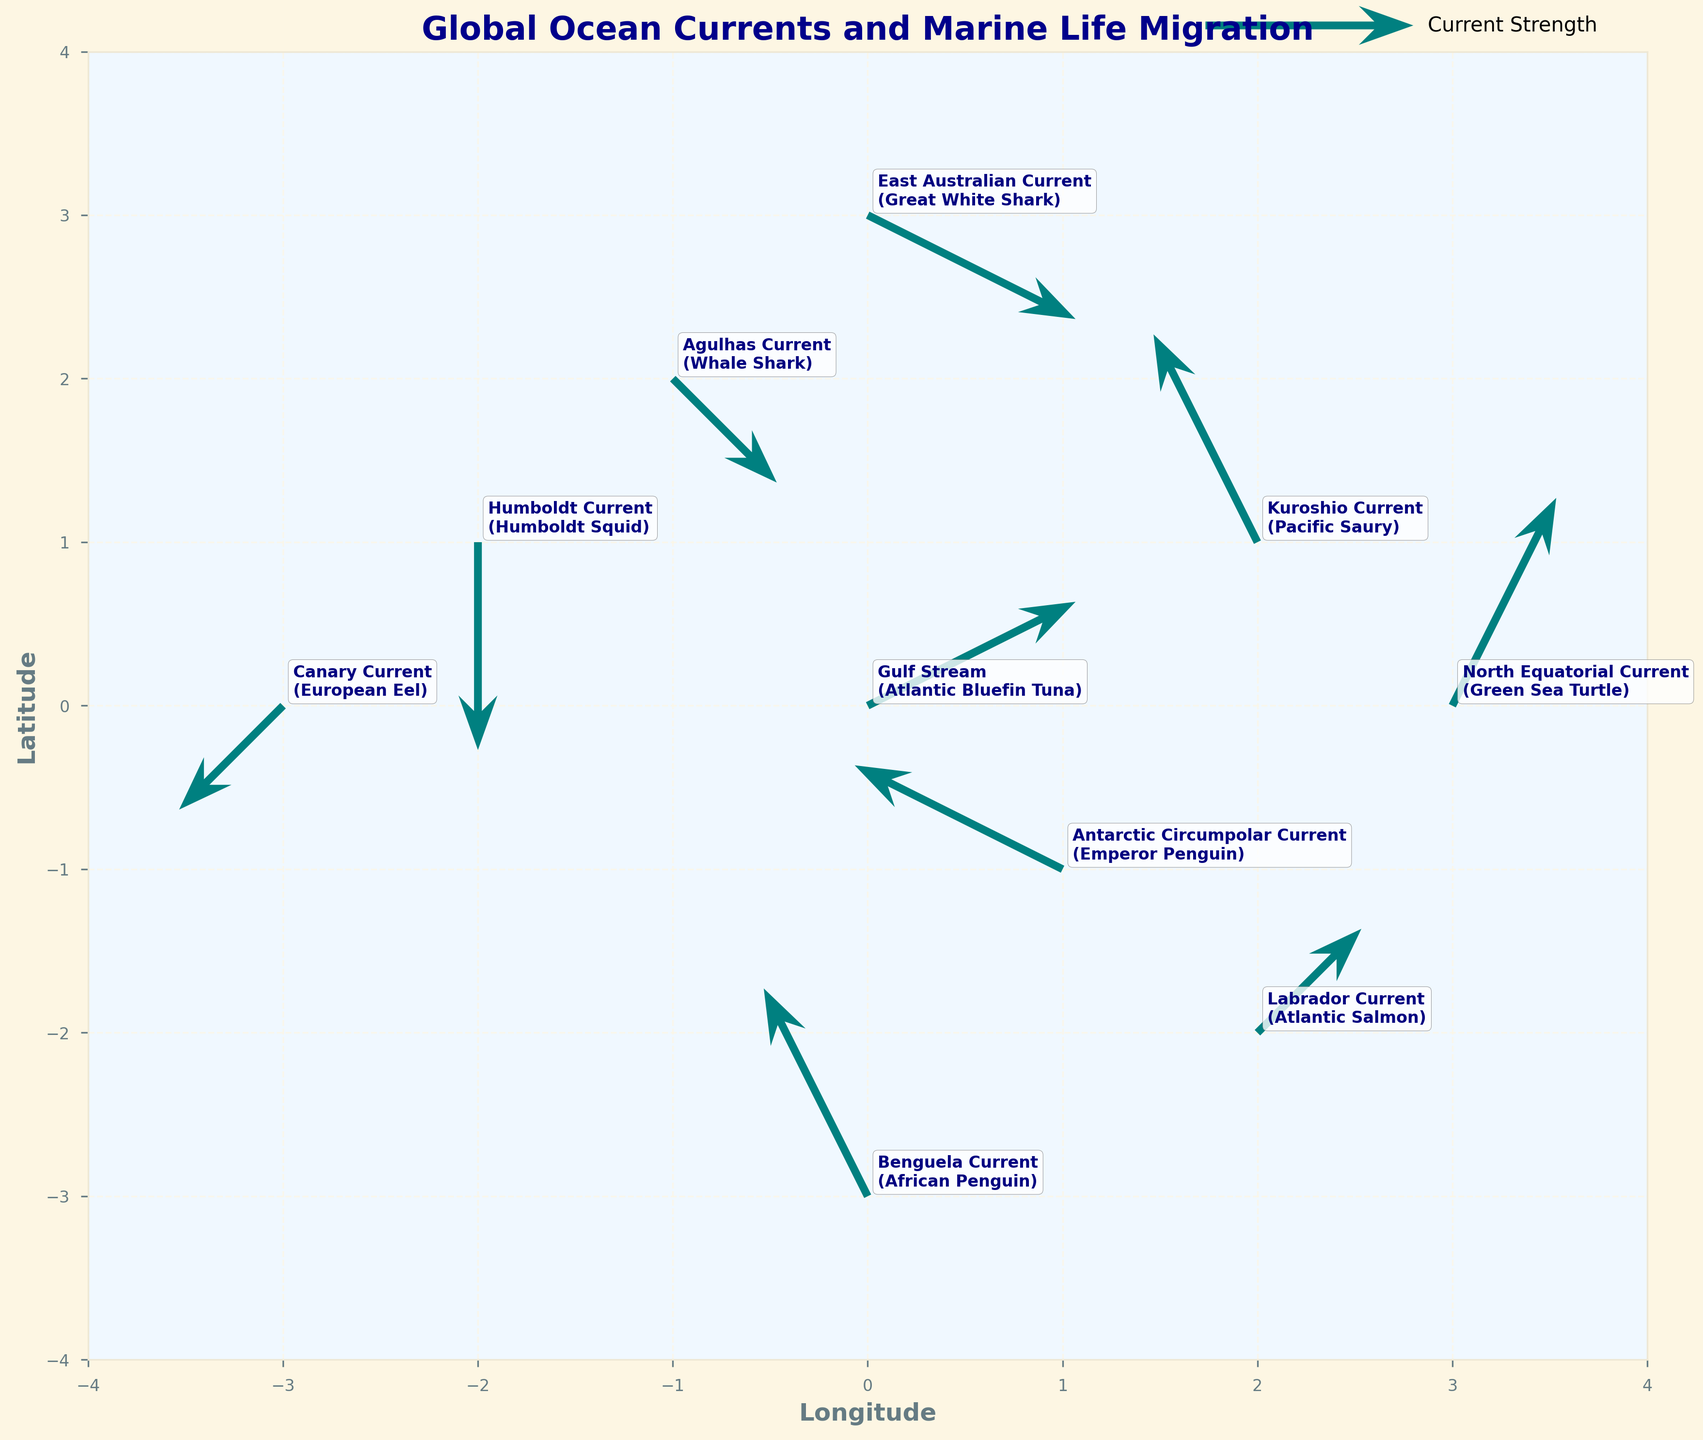What's the title of the plot? The title of the plot is located at the top of the figure. It provides a summary of what the plot represents.
Answer: Global Ocean Currents and Marine Life Migration How many currents are shown in the figure? You can count the number of labeled points on the figure, each representing a different current.
Answer: 10 What current is associated with the Atlantic Bluefin Tuna? By looking at the labels near each arrow on the plot, you can find the current that lists the Atlantic Bluefin Tuna.
Answer: Gulf Stream Which marine species is affected by the Humboldt Current? Locate the Humboldt Current label in the plot and read the species name that is associated with it.
Answer: Humboldt Squid How do the directions of the Gulf Stream and the Canary Current compare? Observe the direction of the arrows originating from the points labeled Gulf Stream and Canary Current. Compare their orientations.
Answer: Gulf Stream points northwest; Canary Current points southwest Which current has the strongest eastward component? The eastward component is represented by the U vector in the data, which is the horizontal arrow in the plot. Compare the magnitudes of the eastward directions.
Answer: North Equatorial Current What is the net directional change of species migration when combining the Antarctic Circumpolar Current and East Australian Current? Look at the vectors representing the Antarctic Circumpolar Current and East Australian Current, add their U and V components separately to get the net directional change.
Answer: (-2 + 2, 1 - 1) -> (0, 0) means no net directional change Which current has the longest resultant vector and what does it signify? The resultant vector length can be calculated by the Pythagorean theorem √(U² + V²). The current with the largest magnitude signifies the strongest current.
Answer: North Equatorial Current; it signifies the strongest current What is the latitude at which the Benguela Current is shown? The latitude is represented by the Y-coordinate in the plot. Locate the Y-coordinate where the Benguela Current label is placed.
Answer: -3 How is the direction of the Labrador Current vector related to Atlantic Salmon migration? Analyze the direction of the arrow of the Labrador Current to understand how it guides the movement of Atlantic Salmon.
Answer: The arrow points northeast, indicating Atlantic Salmon might migrate in a northeast direction What direction does the Kuroshio Current flow? Observe the arrow direction originating from the Kuroshio Current label.
Answer: Northeast 